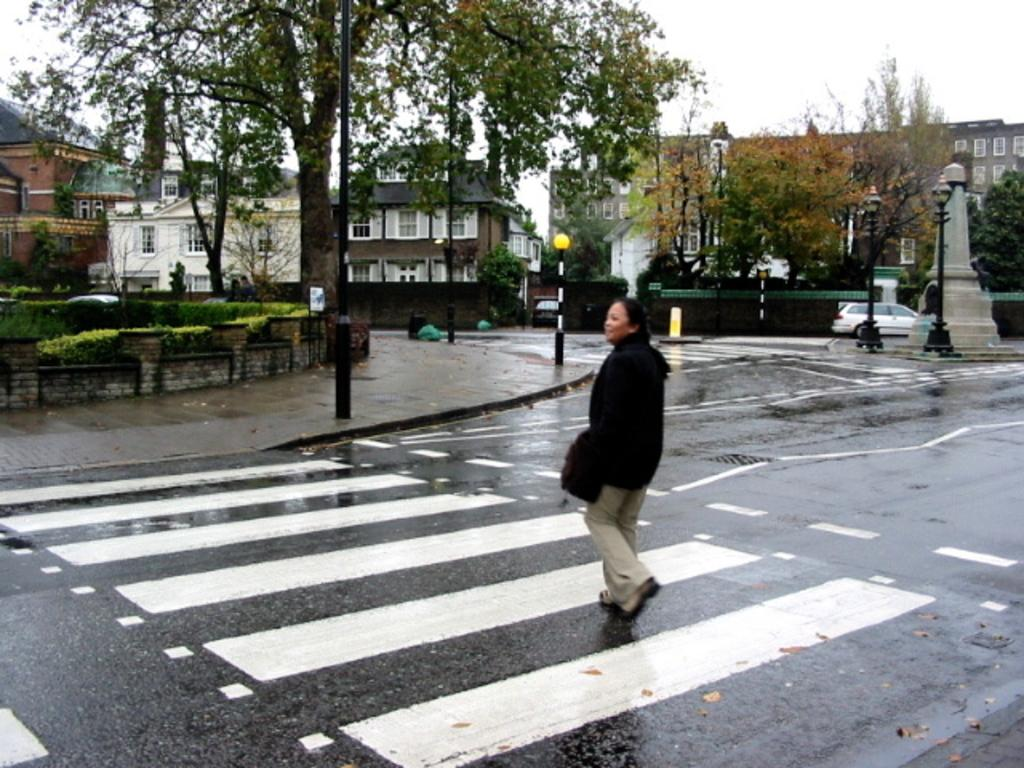What is the lady in the image doing? The lady is walking in the image. Where is the lady located in the image? The lady is on the road in the image. What can be seen in the background of the image? There are buildings and trees in the background of the image. What is visible at the top of the image? The sky is visible at the top of the image. How many jellyfish can be seen swimming in the image? There are no jellyfish present in the image. 